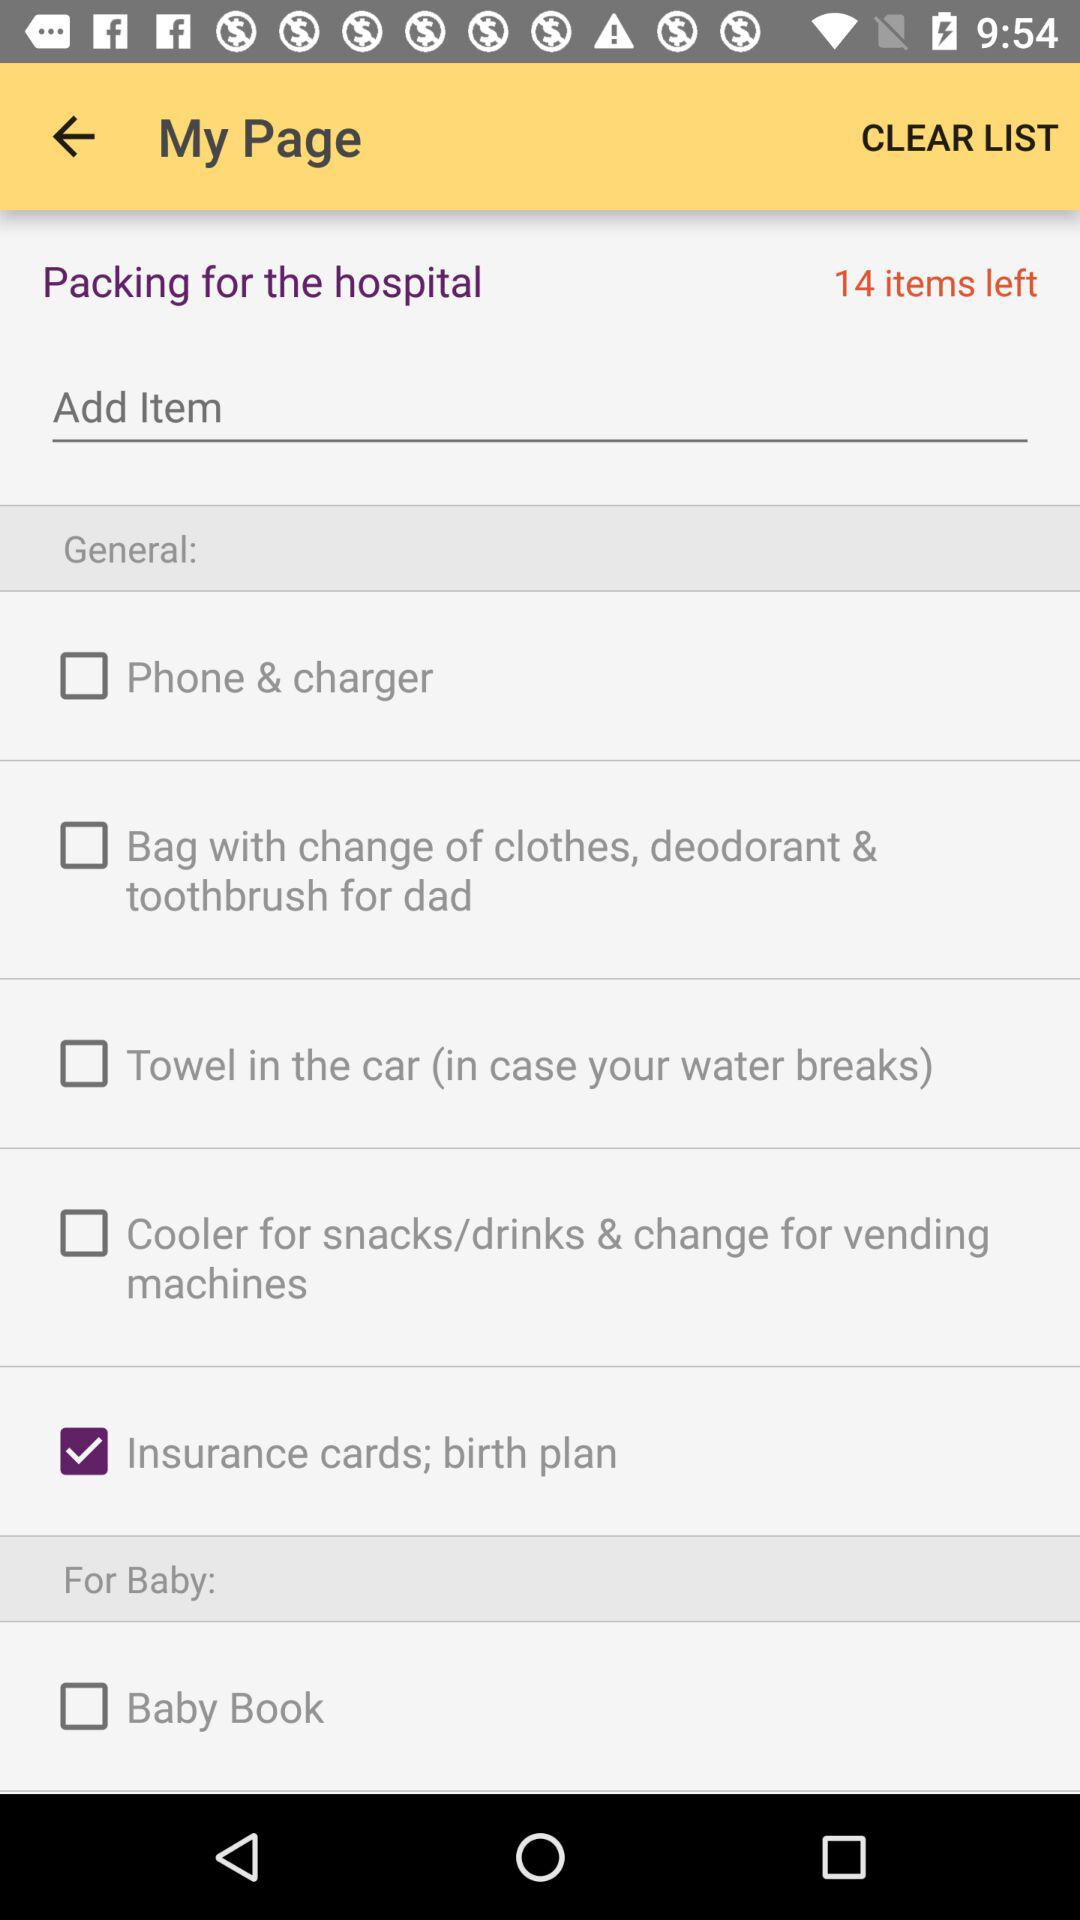Which option is checked in "General"? The checked option is "Insurance cards; birth plan". 